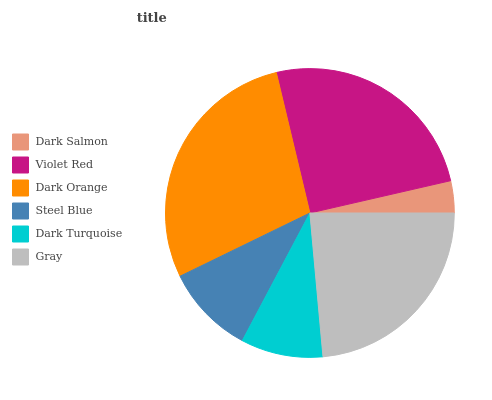Is Dark Salmon the minimum?
Answer yes or no. Yes. Is Dark Orange the maximum?
Answer yes or no. Yes. Is Violet Red the minimum?
Answer yes or no. No. Is Violet Red the maximum?
Answer yes or no. No. Is Violet Red greater than Dark Salmon?
Answer yes or no. Yes. Is Dark Salmon less than Violet Red?
Answer yes or no. Yes. Is Dark Salmon greater than Violet Red?
Answer yes or no. No. Is Violet Red less than Dark Salmon?
Answer yes or no. No. Is Gray the high median?
Answer yes or no. Yes. Is Steel Blue the low median?
Answer yes or no. Yes. Is Steel Blue the high median?
Answer yes or no. No. Is Violet Red the low median?
Answer yes or no. No. 